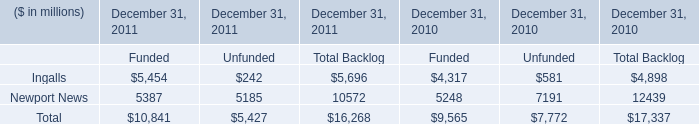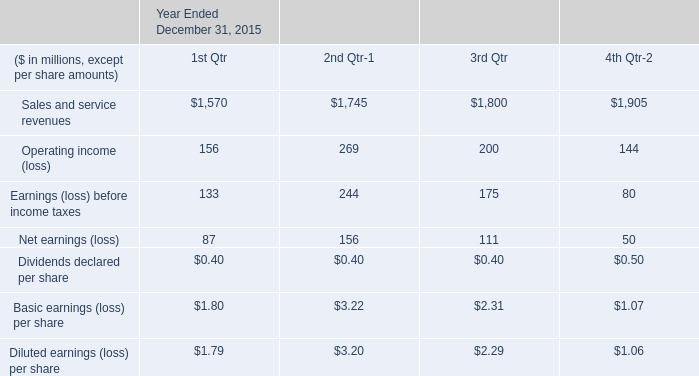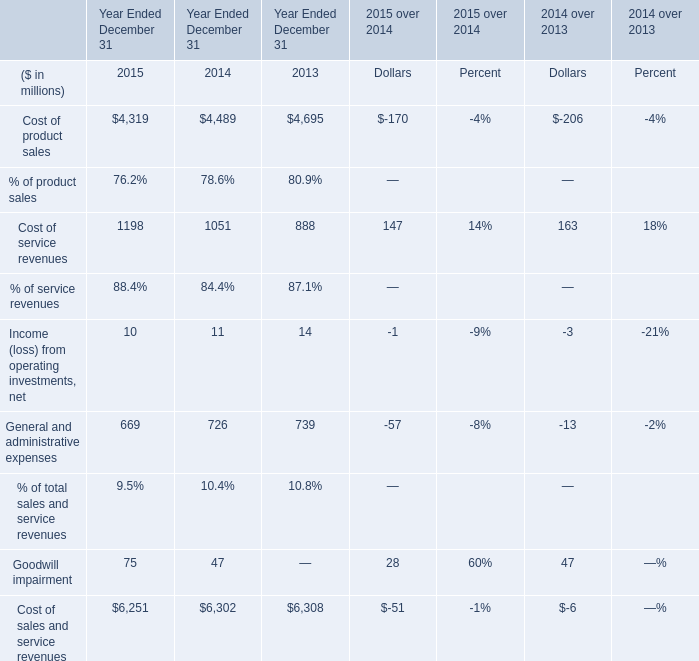What is the sum of Year Ended December 31 in 2015 ? 
Answer: 6251. 